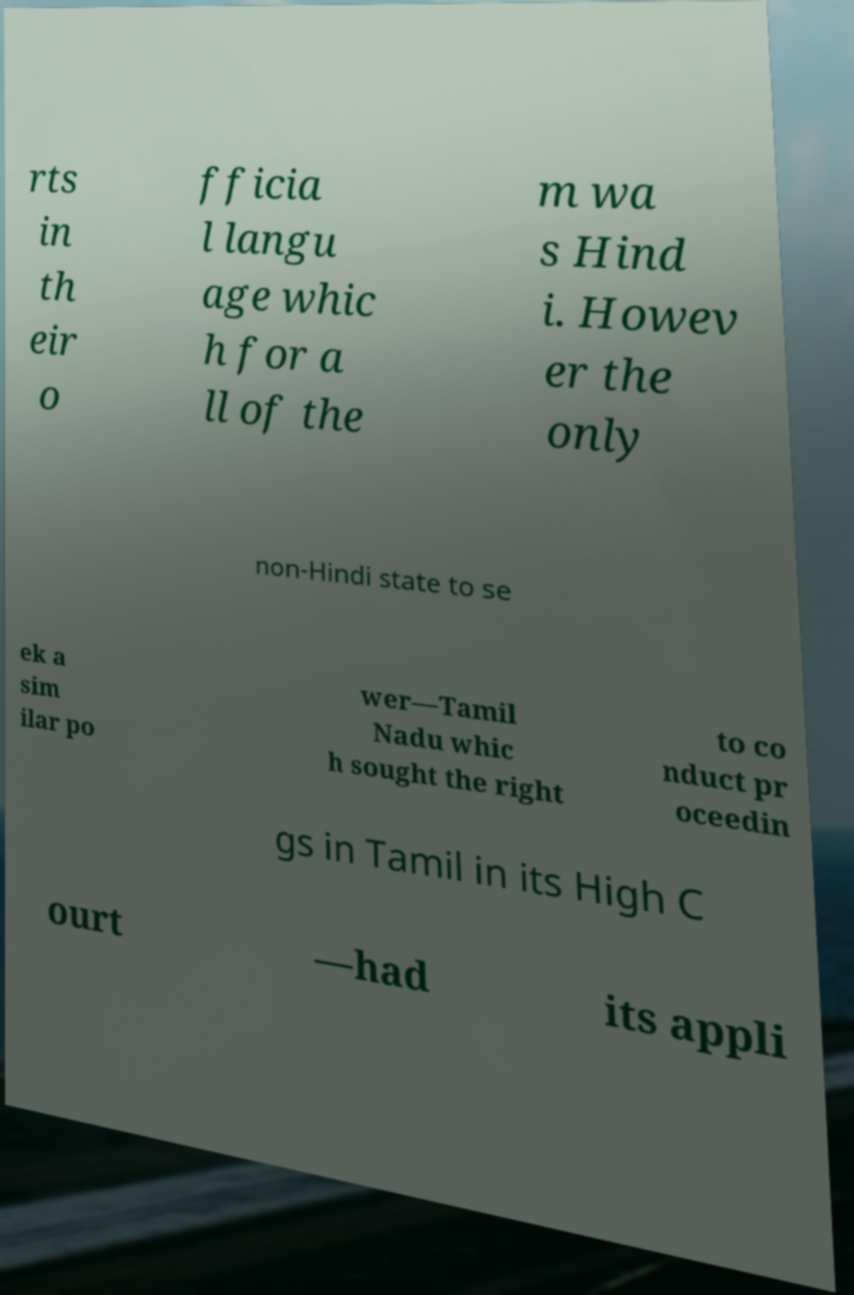Could you extract and type out the text from this image? rts in th eir o fficia l langu age whic h for a ll of the m wa s Hind i. Howev er the only non-Hindi state to se ek a sim ilar po wer—Tamil Nadu whic h sought the right to co nduct pr oceedin gs in Tamil in its High C ourt —had its appli 